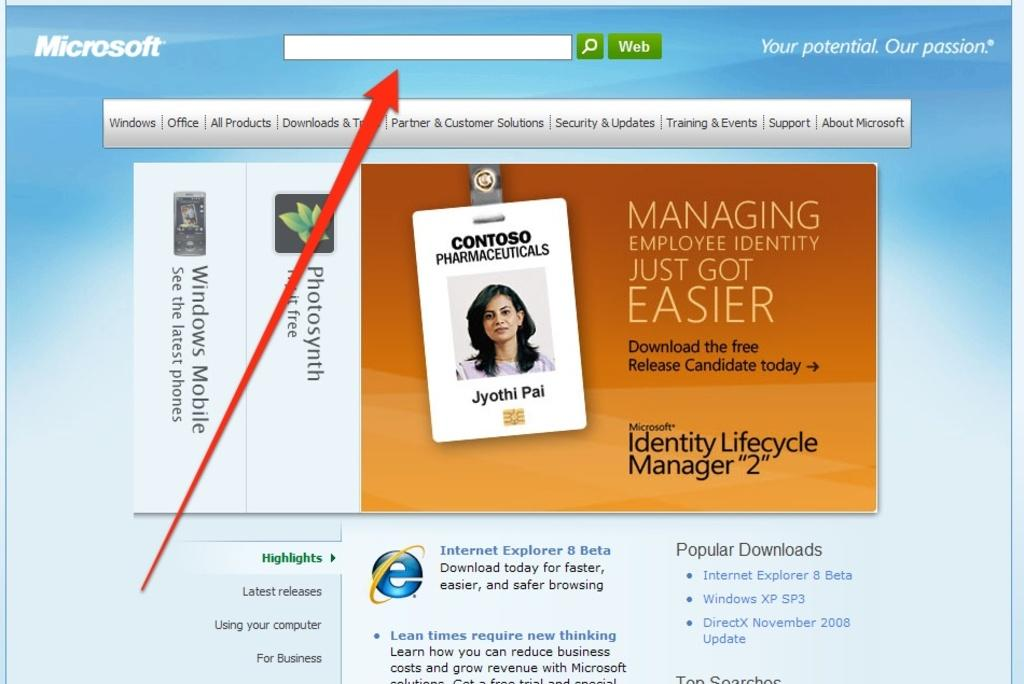What type of content is displayed in the image? There is a page of a website in the image. What elements can be found on the website page? The website page contains text and images. Can you describe a specific image on the website page? There is a photo of a person on the website page. What kind of visual representation of the website can be seen on the page? There is a logo on the website page. How many volleyballs are visible on the website page? There are no volleyballs visible on the website page; the image only contains a page of a website with text, images, a photo of a person, and a logo. 